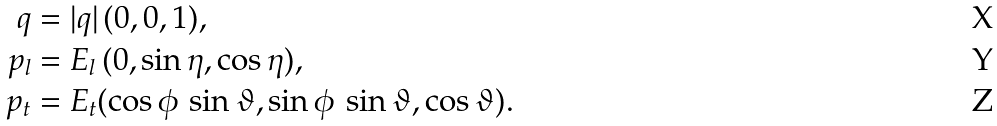Convert formula to latex. <formula><loc_0><loc_0><loc_500><loc_500>q & = | q | \, ( 0 , 0 , 1 ) , \\ p _ { l } & = E _ { l } \, ( 0 , \sin \eta , \cos \eta ) , \\ p _ { t } & = E _ { t } ( \cos \phi \, \sin \vartheta , \sin \phi \, \sin \vartheta , \cos \vartheta ) .</formula> 